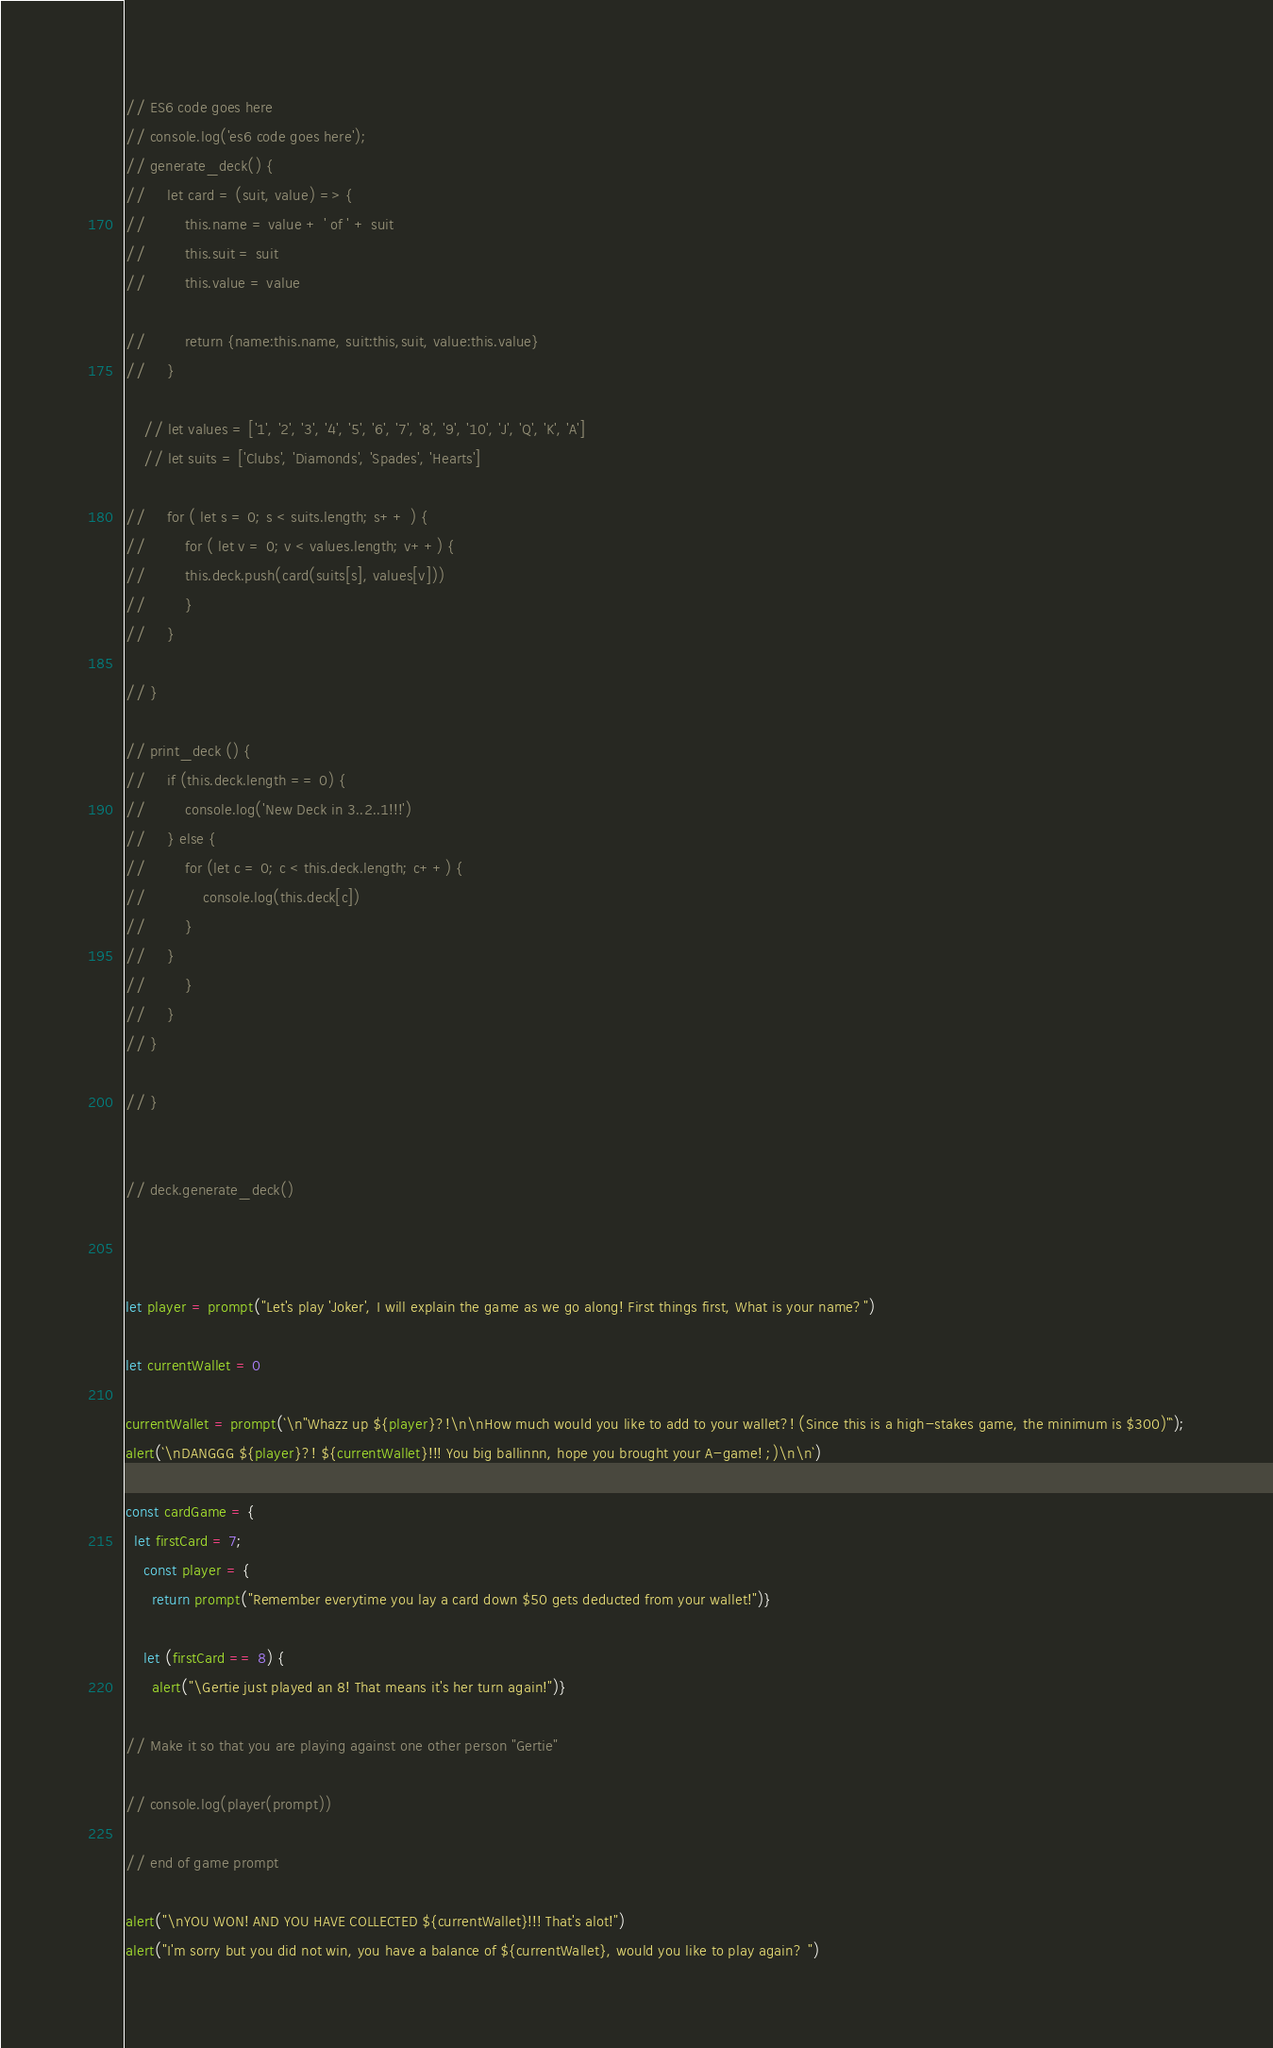<code> <loc_0><loc_0><loc_500><loc_500><_JavaScript_>// ES6 code goes here
// console.log('es6 code goes here');
// generate_deck() {
//     let card = (suit, value) => {
//         this.name = value + ' of ' + suit
//         this.suit = suit 
//         this.value = value 

//         return {name:this.name, suit:this,suit, value:this.value}
//     }

    // let values = ['1', '2', '3', '4', '5', '6', '7', '8', '9', '10', 'J', 'Q', 'K', 'A']
    // let suits = ['Clubs', 'Diamonds', 'Spades', 'Hearts']

//     for ( let s = 0; s < suits.length; s++ ) {
//         for ( let v = 0; v < values.length; v++) {
//         this.deck.push(card(suits[s], values[v]))
//         }
//     }

// }

// print_deck () {
//     if (this.deck.length == 0) {
//         console.log('New Deck in 3..2..1!!!')
//     } else {
//         for (let c = 0; c < this.deck.length; c++) {
//             console.log(this.deck[c])
//         }
//     }
//         }
//     }
// }

// }


// deck.generate_deck()



let player = prompt("Let's play 'Joker', I will explain the game as we go along! First things first, What is your name?")

let currentWallet = 0

currentWallet = prompt(`\n"Whazz up ${player}?!\n\nHow much would you like to add to your wallet?! (Since this is a high-stakes game, the minimum is $300)"`);
alert(`\nDANGGG ${player}?! ${currentWallet}!!! You big ballinnn, hope you brought your A-game! ;)\n\n`)

const cardGame = {
  let firstCard = 7;
    const player = {
      return prompt("Remember everytime you lay a card down $50 gets deducted from your wallet!")}
      
    let (firstCard == 8) {
      alert("\Gertie just played an 8! That means it's her turn again!")}

// Make it so that you are playing against one other person "Gertie"

// console.log(player(prompt))

// end of game prompt 

alert("\nYOU WON! AND YOU HAVE COLLECTED ${currentWallet}!!! That's alot!")
alert("I'm sorry but you did not win, you have a balance of ${currentWallet}, would you like to play again? ")
</code> 